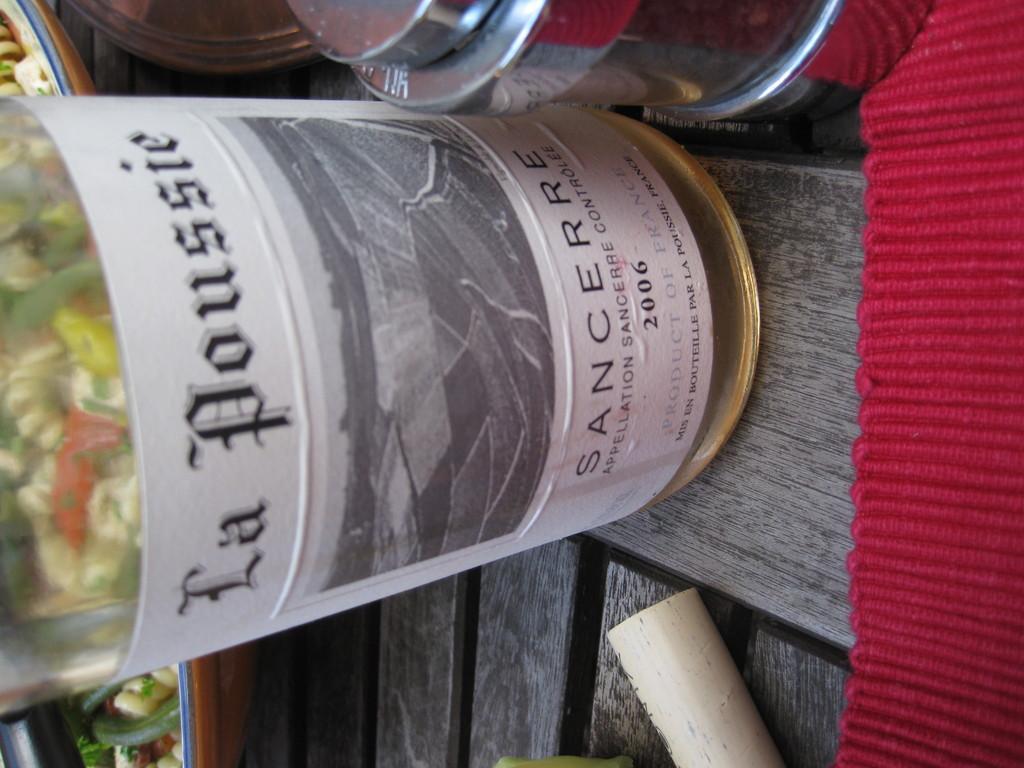How would you summarize this image in a sentence or two? As we can see in the image there is a table. On table there is red color mat. bottle and boxes. 